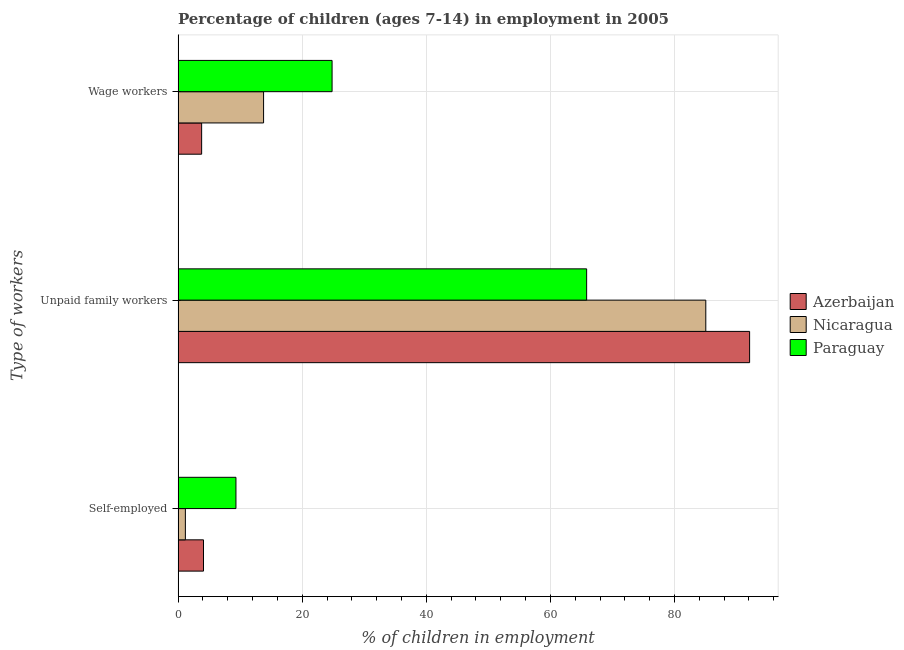How many different coloured bars are there?
Provide a succinct answer. 3. Are the number of bars per tick equal to the number of legend labels?
Ensure brevity in your answer.  Yes. How many bars are there on the 1st tick from the bottom?
Offer a terse response. 3. What is the label of the 1st group of bars from the top?
Give a very brief answer. Wage workers. What is the percentage of self employed children in Nicaragua?
Give a very brief answer. 1.18. Across all countries, what is the maximum percentage of children employed as wage workers?
Your answer should be compact. 24.82. Across all countries, what is the minimum percentage of children employed as unpaid family workers?
Provide a succinct answer. 65.84. In which country was the percentage of self employed children maximum?
Your answer should be very brief. Paraguay. In which country was the percentage of self employed children minimum?
Your answer should be very brief. Nicaragua. What is the total percentage of children employed as unpaid family workers in the graph?
Your answer should be very brief. 242.98. What is the difference between the percentage of children employed as wage workers in Nicaragua and that in Paraguay?
Your answer should be compact. -11.04. What is the difference between the percentage of self employed children in Azerbaijan and the percentage of children employed as wage workers in Paraguay?
Provide a short and direct response. -20.72. What is the average percentage of self employed children per country?
Offer a very short reply. 4.87. What is the difference between the percentage of children employed as wage workers and percentage of self employed children in Paraguay?
Give a very brief answer. 15.49. In how many countries, is the percentage of self employed children greater than 92 %?
Offer a terse response. 0. What is the ratio of the percentage of children employed as unpaid family workers in Azerbaijan to that in Nicaragua?
Provide a succinct answer. 1.08. Is the difference between the percentage of self employed children in Nicaragua and Paraguay greater than the difference between the percentage of children employed as unpaid family workers in Nicaragua and Paraguay?
Keep it short and to the point. No. What is the difference between the highest and the second highest percentage of children employed as unpaid family workers?
Provide a succinct answer. 7.06. What is the difference between the highest and the lowest percentage of self employed children?
Offer a terse response. 8.15. In how many countries, is the percentage of children employed as wage workers greater than the average percentage of children employed as wage workers taken over all countries?
Your answer should be very brief. 1. Is the sum of the percentage of self employed children in Azerbaijan and Paraguay greater than the maximum percentage of children employed as unpaid family workers across all countries?
Offer a terse response. No. What does the 1st bar from the top in Self-employed represents?
Your answer should be very brief. Paraguay. What does the 3rd bar from the bottom in Wage workers represents?
Ensure brevity in your answer.  Paraguay. How many bars are there?
Give a very brief answer. 9. Are all the bars in the graph horizontal?
Offer a very short reply. Yes. Does the graph contain grids?
Your response must be concise. Yes. How are the legend labels stacked?
Provide a succinct answer. Vertical. What is the title of the graph?
Provide a short and direct response. Percentage of children (ages 7-14) in employment in 2005. What is the label or title of the X-axis?
Make the answer very short. % of children in employment. What is the label or title of the Y-axis?
Provide a short and direct response. Type of workers. What is the % of children in employment in Nicaragua in Self-employed?
Ensure brevity in your answer.  1.18. What is the % of children in employment of Paraguay in Self-employed?
Offer a very short reply. 9.33. What is the % of children in employment of Azerbaijan in Unpaid family workers?
Your answer should be compact. 92.1. What is the % of children in employment of Nicaragua in Unpaid family workers?
Ensure brevity in your answer.  85.04. What is the % of children in employment in Paraguay in Unpaid family workers?
Keep it short and to the point. 65.84. What is the % of children in employment in Azerbaijan in Wage workers?
Your response must be concise. 3.8. What is the % of children in employment in Nicaragua in Wage workers?
Your response must be concise. 13.78. What is the % of children in employment of Paraguay in Wage workers?
Your answer should be very brief. 24.82. Across all Type of workers, what is the maximum % of children in employment in Azerbaijan?
Make the answer very short. 92.1. Across all Type of workers, what is the maximum % of children in employment in Nicaragua?
Provide a short and direct response. 85.04. Across all Type of workers, what is the maximum % of children in employment in Paraguay?
Offer a very short reply. 65.84. Across all Type of workers, what is the minimum % of children in employment in Azerbaijan?
Give a very brief answer. 3.8. Across all Type of workers, what is the minimum % of children in employment in Nicaragua?
Give a very brief answer. 1.18. Across all Type of workers, what is the minimum % of children in employment of Paraguay?
Your response must be concise. 9.33. What is the total % of children in employment of Azerbaijan in the graph?
Offer a very short reply. 100. What is the total % of children in employment of Paraguay in the graph?
Offer a very short reply. 99.99. What is the difference between the % of children in employment of Azerbaijan in Self-employed and that in Unpaid family workers?
Provide a short and direct response. -88. What is the difference between the % of children in employment of Nicaragua in Self-employed and that in Unpaid family workers?
Make the answer very short. -83.86. What is the difference between the % of children in employment of Paraguay in Self-employed and that in Unpaid family workers?
Provide a short and direct response. -56.51. What is the difference between the % of children in employment in Azerbaijan in Self-employed and that in Wage workers?
Keep it short and to the point. 0.3. What is the difference between the % of children in employment of Nicaragua in Self-employed and that in Wage workers?
Offer a very short reply. -12.6. What is the difference between the % of children in employment of Paraguay in Self-employed and that in Wage workers?
Make the answer very short. -15.49. What is the difference between the % of children in employment in Azerbaijan in Unpaid family workers and that in Wage workers?
Offer a very short reply. 88.3. What is the difference between the % of children in employment of Nicaragua in Unpaid family workers and that in Wage workers?
Your response must be concise. 71.26. What is the difference between the % of children in employment of Paraguay in Unpaid family workers and that in Wage workers?
Your response must be concise. 41.02. What is the difference between the % of children in employment of Azerbaijan in Self-employed and the % of children in employment of Nicaragua in Unpaid family workers?
Ensure brevity in your answer.  -80.94. What is the difference between the % of children in employment in Azerbaijan in Self-employed and the % of children in employment in Paraguay in Unpaid family workers?
Give a very brief answer. -61.74. What is the difference between the % of children in employment of Nicaragua in Self-employed and the % of children in employment of Paraguay in Unpaid family workers?
Keep it short and to the point. -64.66. What is the difference between the % of children in employment in Azerbaijan in Self-employed and the % of children in employment in Nicaragua in Wage workers?
Make the answer very short. -9.68. What is the difference between the % of children in employment in Azerbaijan in Self-employed and the % of children in employment in Paraguay in Wage workers?
Make the answer very short. -20.72. What is the difference between the % of children in employment of Nicaragua in Self-employed and the % of children in employment of Paraguay in Wage workers?
Your answer should be compact. -23.64. What is the difference between the % of children in employment in Azerbaijan in Unpaid family workers and the % of children in employment in Nicaragua in Wage workers?
Your answer should be very brief. 78.32. What is the difference between the % of children in employment in Azerbaijan in Unpaid family workers and the % of children in employment in Paraguay in Wage workers?
Your answer should be very brief. 67.28. What is the difference between the % of children in employment of Nicaragua in Unpaid family workers and the % of children in employment of Paraguay in Wage workers?
Ensure brevity in your answer.  60.22. What is the average % of children in employment in Azerbaijan per Type of workers?
Your response must be concise. 33.33. What is the average % of children in employment of Nicaragua per Type of workers?
Your answer should be compact. 33.33. What is the average % of children in employment of Paraguay per Type of workers?
Make the answer very short. 33.33. What is the difference between the % of children in employment of Azerbaijan and % of children in employment of Nicaragua in Self-employed?
Your answer should be very brief. 2.92. What is the difference between the % of children in employment in Azerbaijan and % of children in employment in Paraguay in Self-employed?
Make the answer very short. -5.23. What is the difference between the % of children in employment of Nicaragua and % of children in employment of Paraguay in Self-employed?
Provide a succinct answer. -8.15. What is the difference between the % of children in employment of Azerbaijan and % of children in employment of Nicaragua in Unpaid family workers?
Your response must be concise. 7.06. What is the difference between the % of children in employment in Azerbaijan and % of children in employment in Paraguay in Unpaid family workers?
Keep it short and to the point. 26.26. What is the difference between the % of children in employment in Azerbaijan and % of children in employment in Nicaragua in Wage workers?
Your response must be concise. -9.98. What is the difference between the % of children in employment in Azerbaijan and % of children in employment in Paraguay in Wage workers?
Your response must be concise. -21.02. What is the difference between the % of children in employment of Nicaragua and % of children in employment of Paraguay in Wage workers?
Ensure brevity in your answer.  -11.04. What is the ratio of the % of children in employment in Azerbaijan in Self-employed to that in Unpaid family workers?
Offer a very short reply. 0.04. What is the ratio of the % of children in employment in Nicaragua in Self-employed to that in Unpaid family workers?
Keep it short and to the point. 0.01. What is the ratio of the % of children in employment in Paraguay in Self-employed to that in Unpaid family workers?
Make the answer very short. 0.14. What is the ratio of the % of children in employment in Azerbaijan in Self-employed to that in Wage workers?
Give a very brief answer. 1.08. What is the ratio of the % of children in employment in Nicaragua in Self-employed to that in Wage workers?
Your response must be concise. 0.09. What is the ratio of the % of children in employment in Paraguay in Self-employed to that in Wage workers?
Provide a succinct answer. 0.38. What is the ratio of the % of children in employment of Azerbaijan in Unpaid family workers to that in Wage workers?
Offer a terse response. 24.24. What is the ratio of the % of children in employment of Nicaragua in Unpaid family workers to that in Wage workers?
Make the answer very short. 6.17. What is the ratio of the % of children in employment in Paraguay in Unpaid family workers to that in Wage workers?
Provide a succinct answer. 2.65. What is the difference between the highest and the second highest % of children in employment of Nicaragua?
Your response must be concise. 71.26. What is the difference between the highest and the second highest % of children in employment of Paraguay?
Your response must be concise. 41.02. What is the difference between the highest and the lowest % of children in employment of Azerbaijan?
Ensure brevity in your answer.  88.3. What is the difference between the highest and the lowest % of children in employment of Nicaragua?
Your answer should be very brief. 83.86. What is the difference between the highest and the lowest % of children in employment in Paraguay?
Your answer should be very brief. 56.51. 